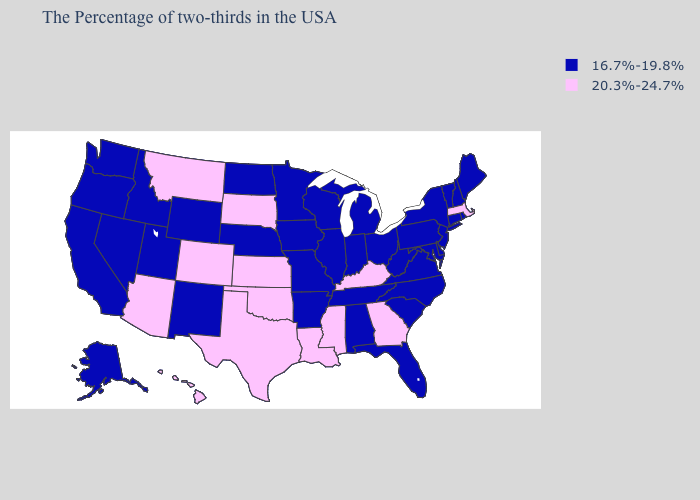Name the states that have a value in the range 20.3%-24.7%?
Be succinct. Massachusetts, Georgia, Kentucky, Mississippi, Louisiana, Kansas, Oklahoma, Texas, South Dakota, Colorado, Montana, Arizona, Hawaii. Name the states that have a value in the range 16.7%-19.8%?
Keep it brief. Maine, Rhode Island, New Hampshire, Vermont, Connecticut, New York, New Jersey, Delaware, Maryland, Pennsylvania, Virginia, North Carolina, South Carolina, West Virginia, Ohio, Florida, Michigan, Indiana, Alabama, Tennessee, Wisconsin, Illinois, Missouri, Arkansas, Minnesota, Iowa, Nebraska, North Dakota, Wyoming, New Mexico, Utah, Idaho, Nevada, California, Washington, Oregon, Alaska. Among the states that border Connecticut , which have the highest value?
Keep it brief. Massachusetts. Does the map have missing data?
Be succinct. No. How many symbols are there in the legend?
Give a very brief answer. 2. What is the value of Ohio?
Give a very brief answer. 16.7%-19.8%. Is the legend a continuous bar?
Concise answer only. No. Does Colorado have the lowest value in the USA?
Give a very brief answer. No. Which states hav the highest value in the South?
Be succinct. Georgia, Kentucky, Mississippi, Louisiana, Oklahoma, Texas. Name the states that have a value in the range 20.3%-24.7%?
Give a very brief answer. Massachusetts, Georgia, Kentucky, Mississippi, Louisiana, Kansas, Oklahoma, Texas, South Dakota, Colorado, Montana, Arizona, Hawaii. Which states have the lowest value in the USA?
Concise answer only. Maine, Rhode Island, New Hampshire, Vermont, Connecticut, New York, New Jersey, Delaware, Maryland, Pennsylvania, Virginia, North Carolina, South Carolina, West Virginia, Ohio, Florida, Michigan, Indiana, Alabama, Tennessee, Wisconsin, Illinois, Missouri, Arkansas, Minnesota, Iowa, Nebraska, North Dakota, Wyoming, New Mexico, Utah, Idaho, Nevada, California, Washington, Oregon, Alaska. Does Kentucky have a higher value than Alabama?
Be succinct. Yes. Does Massachusetts have the lowest value in the Northeast?
Quick response, please. No. Which states have the lowest value in the Northeast?
Give a very brief answer. Maine, Rhode Island, New Hampshire, Vermont, Connecticut, New York, New Jersey, Pennsylvania. 